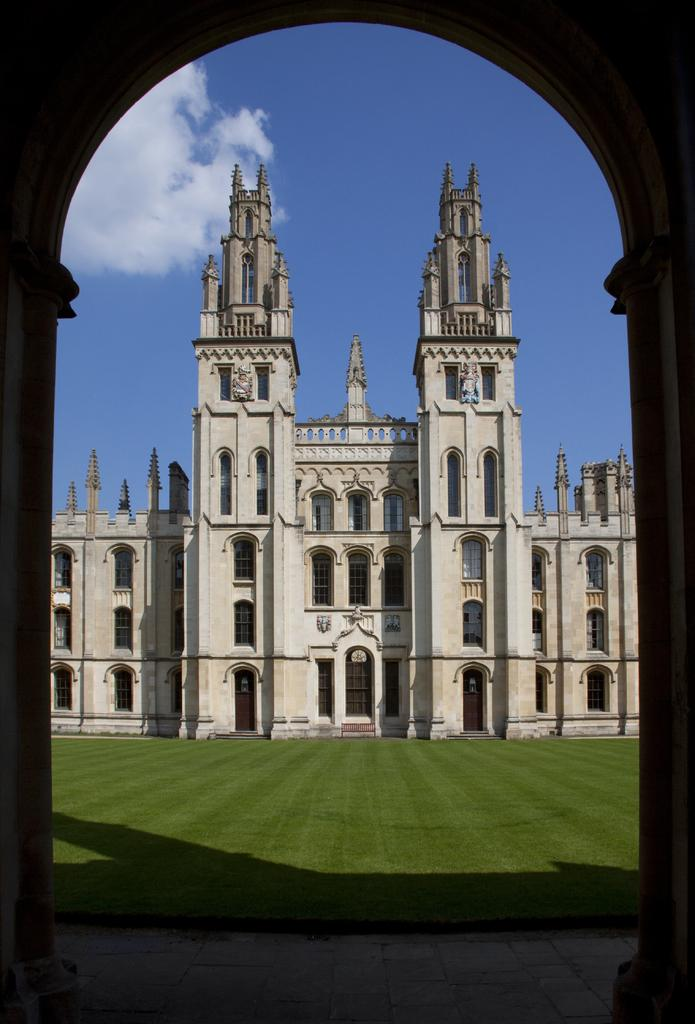What is the main structure visible in the image? There is an arch in the image. What can be seen through the arch? Through the arch, we can see a building, walls, windows, doors, stairs, pillars, grass, and the sky. What is at the bottom of the image? There is a walkway at the bottom of the image. How many points are visible in the image? There is no mention of points in the image; the focus is on the arch, the elements visible through it, and the walkway at the bottom. --- Facts: 1. There is a person holding a book in the image. 2. The person is sitting on a chair. 3. The chair is made of wood. 4. The book has a blue cover. 5. There is a table next to the chair. 6. The table has a lamp on it. 7. The lamp has a green shade. Absurd Topics: elephant, ocean, bicycle Conversation: What is the person in the image holding? The person is holding a book in the image. What is the person sitting on? The person is sitting on a chair. What is the chair made of? The chair is made of wood. What color is the book cover? The book has a blue cover. What is next to the chair? There is a table next to the chair. What is on the table? There is a lamp on the table. What color is the lamp shade? The lamp shade is green. Reasoning: Let's think step by step in order to produce the conversation. We start by identifying the main subject in the image, which is the person holding a book. Then, we describe the person's actions and the objects around them, such as the chair, the table, and the lamp. We ensure that each question can be answered definitively with the information given. Absurd Question/Answer: How many elephants can be seen swimming in the ocean in the image? There are no elephants or ocean visible in the image. 